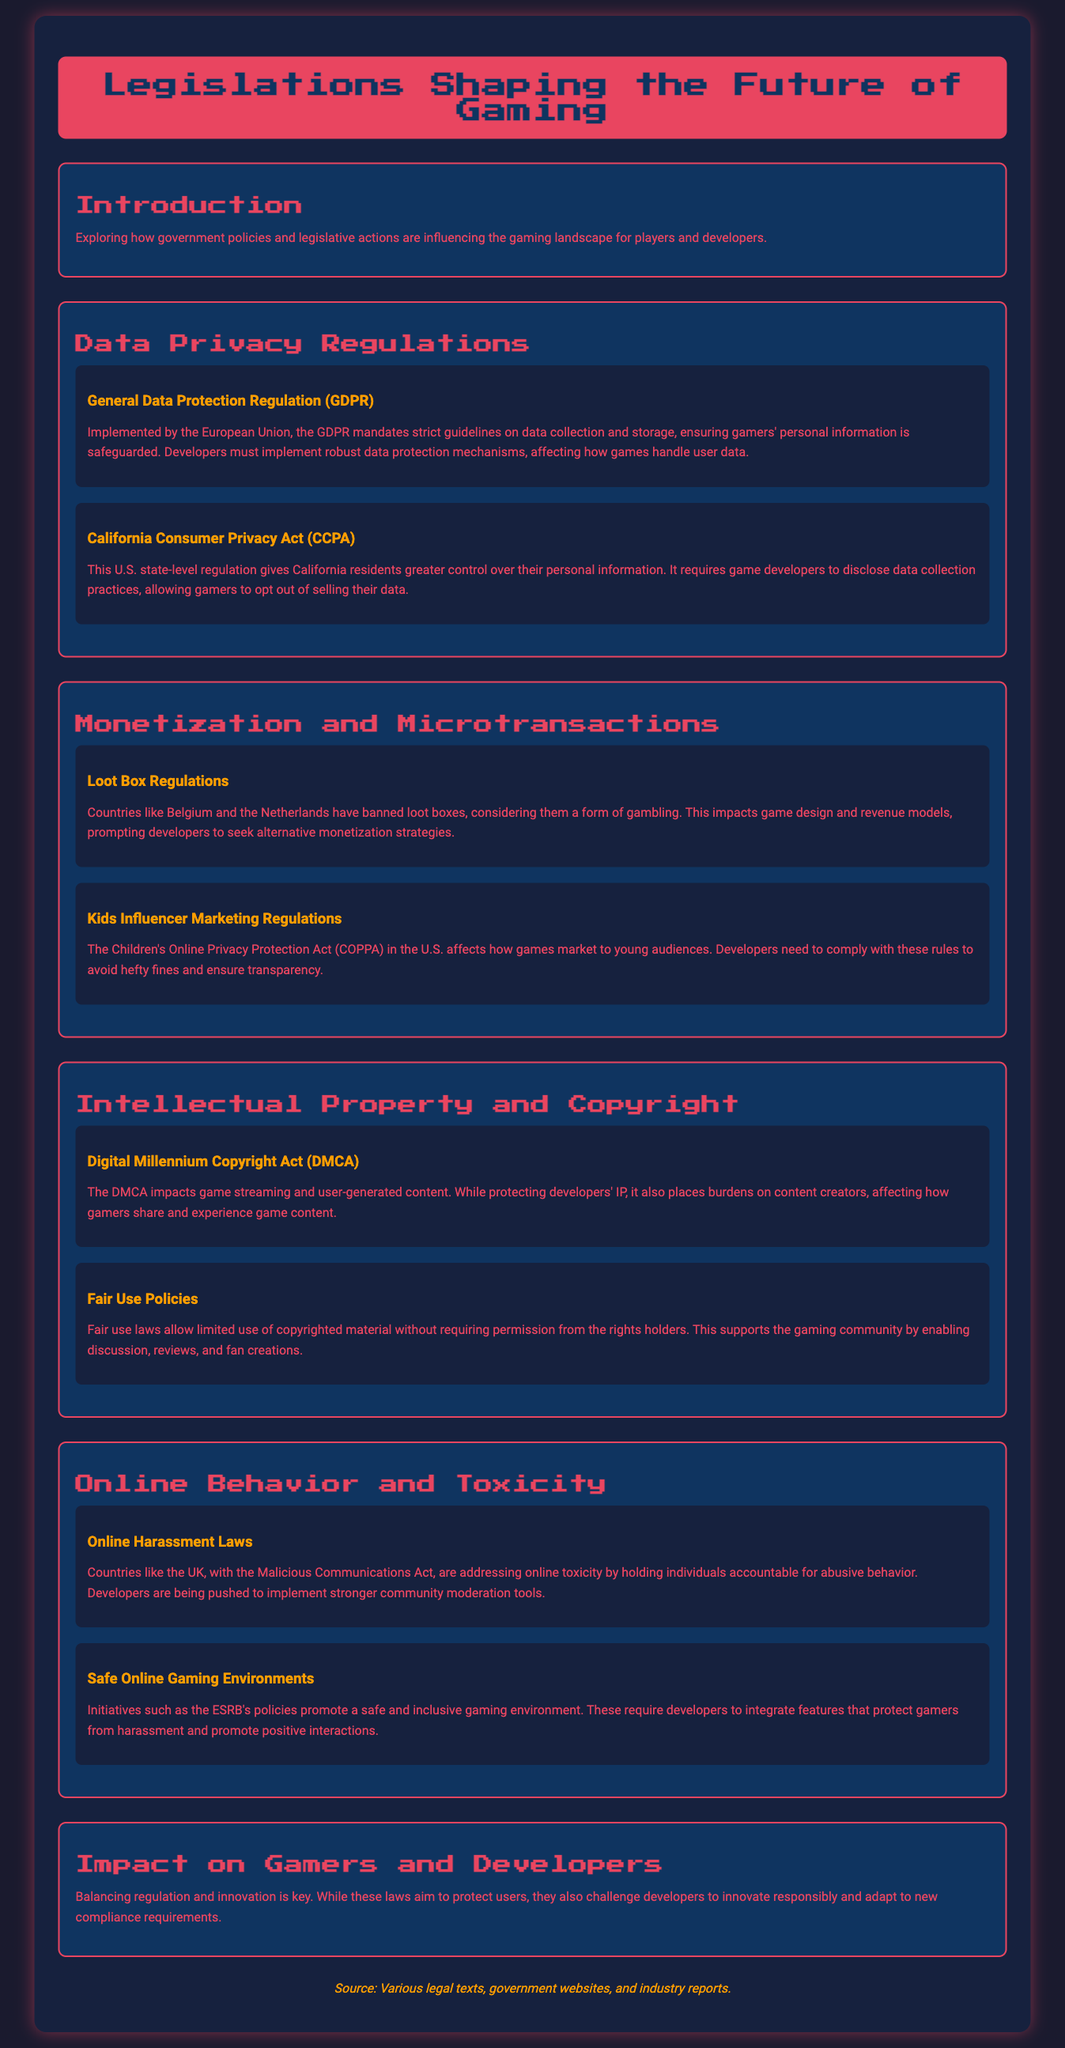What is the purpose of the GDPR? The GDPR mandates strict guidelines on data collection and storage, ensuring gamers' personal information is safeguarded.
Answer: Safeguard personal information Which U.S. regulation allows gamers to opt out of selling their data? The CCPA gives California residents greater control over their personal information, allowing them to opt out.
Answer: CCPA Which two countries have banned loot boxes? Countries like Belgium and the Netherlands have banned loot boxes, considering them a form of gambling.
Answer: Belgium and Netherlands What act impacts online toxicity by holding individuals accountable? The Malicious Communications Act addresses online toxicity by holding individuals accountable for abusive behavior.
Answer: Malicious Communications Act What is the role of fair use laws in gaming? Fair use laws allow limited use of copyrighted material without requiring permission from the rights holders, supporting discussion and fan creations.
Answer: Support discussion and fan creations What do safe online gaming initiatives promote? Initiatives such as the ESRB's policies promote a safe and inclusive gaming environment.
Answer: Safe and inclusive gaming environment What is necessary for developers to comply with COPPA? Developers need to comply with COPPA rules to avoid hefty fines and ensure transparency in marketing to young audiences.
Answer: Comply with COPPA rules What is the focus of the section on Impact on Gamers and Developers? Balancing regulation and innovation is key; laws aim to protect users while challenging developers to innovate responsibly.
Answer: Balancing regulation and innovation 